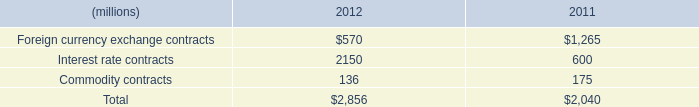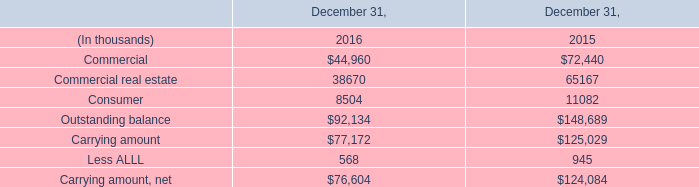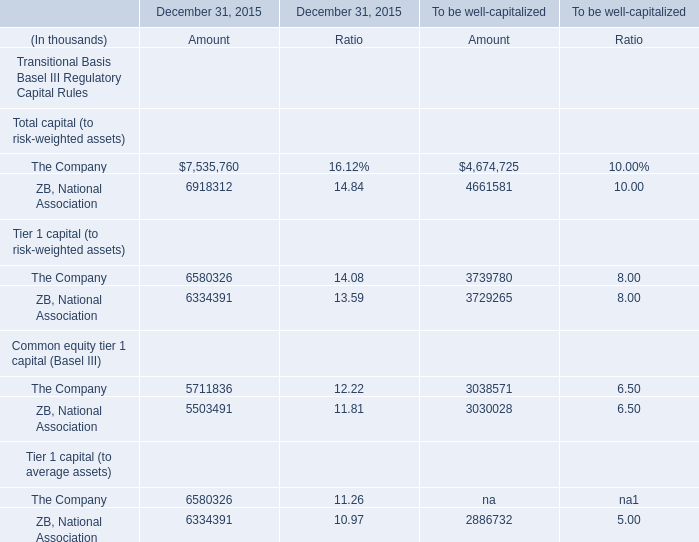by what percent did the total notional amount of the company's derivatives increase between 2011 and 2012? 
Computations: ((2856 - 2040) / 2040)
Answer: 0.4. 